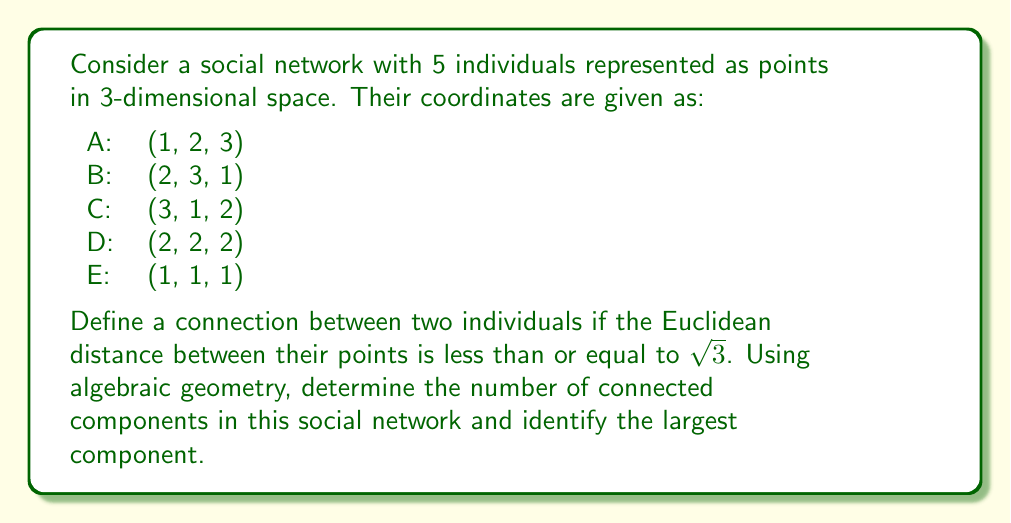Can you solve this math problem? To solve this problem, we'll follow these steps:

1) First, we need to calculate the Euclidean distances between all pairs of points. The Euclidean distance between two points $(x_1, y_1, z_1)$ and $(x_2, y_2, z_2)$ is given by:

   $$d = \sqrt{(x_2-x_1)^2 + (y_2-y_1)^2 + (z_2-z_1)^2}$$

2) Let's calculate these distances:

   AB: $\sqrt{(2-1)^2 + (3-2)^2 + (1-3)^2} = \sqrt{1 + 1 + 4} = \sqrt{6}$
   AC: $\sqrt{(3-1)^2 + (1-2)^2 + (2-3)^2} = \sqrt{4 + 1 + 1} = \sqrt{6}$
   AD: $\sqrt{(2-1)^2 + (2-2)^2 + (2-3)^2} = \sqrt{1 + 0 + 1} = \sqrt{2}$
   AE: $\sqrt{(1-1)^2 + (1-2)^2 + (1-3)^2} = \sqrt{0 + 1 + 4} = \sqrt{5}$
   BC: $\sqrt{(3-2)^2 + (1-3)^2 + (2-1)^2} = \sqrt{1 + 4 + 1} = \sqrt{6}$
   BD: $\sqrt{(2-2)^2 + (2-3)^2 + (2-1)^2} = \sqrt{0 + 1 + 1} = \sqrt{2}$
   BE: $\sqrt{(1-2)^2 + (1-3)^2 + (1-1)^2} = \sqrt{1 + 4 + 0} = \sqrt{5}$
   CD: $\sqrt{(2-3)^2 + (2-1)^2 + (2-2)^2} = \sqrt{1 + 1 + 0} = \sqrt{2}$
   CE: $\sqrt{(1-3)^2 + (1-1)^2 + (1-2)^2} = \sqrt{4 + 0 + 1} = \sqrt{5}$
   DE: $\sqrt{(1-2)^2 + (1-2)^2 + (1-2)^2} = \sqrt{1 + 1 + 1} = \sqrt{3}$

3) Now, we connect points if their distance is less than or equal to $\sqrt{3}$. From our calculations, we can see that:
   - A is connected to D
   - B is connected to D
   - C is connected to D
   - D is connected to E

4) This forms one connected component containing all 5 points: A-D-B-C-D-E

5) Therefore, there is only one connected component, which is also the largest component, containing all 5 points.

From an algebraic geometry perspective, we can view this social network as a variety in $\mathbb{R}^3$. The connections between individuals form a graph, which can be seen as a 1-dimensional algebraic variety (a union of line segments) embedded in 3-dimensional space.
Answer: 1 connected component; largest component includes all 5 points 